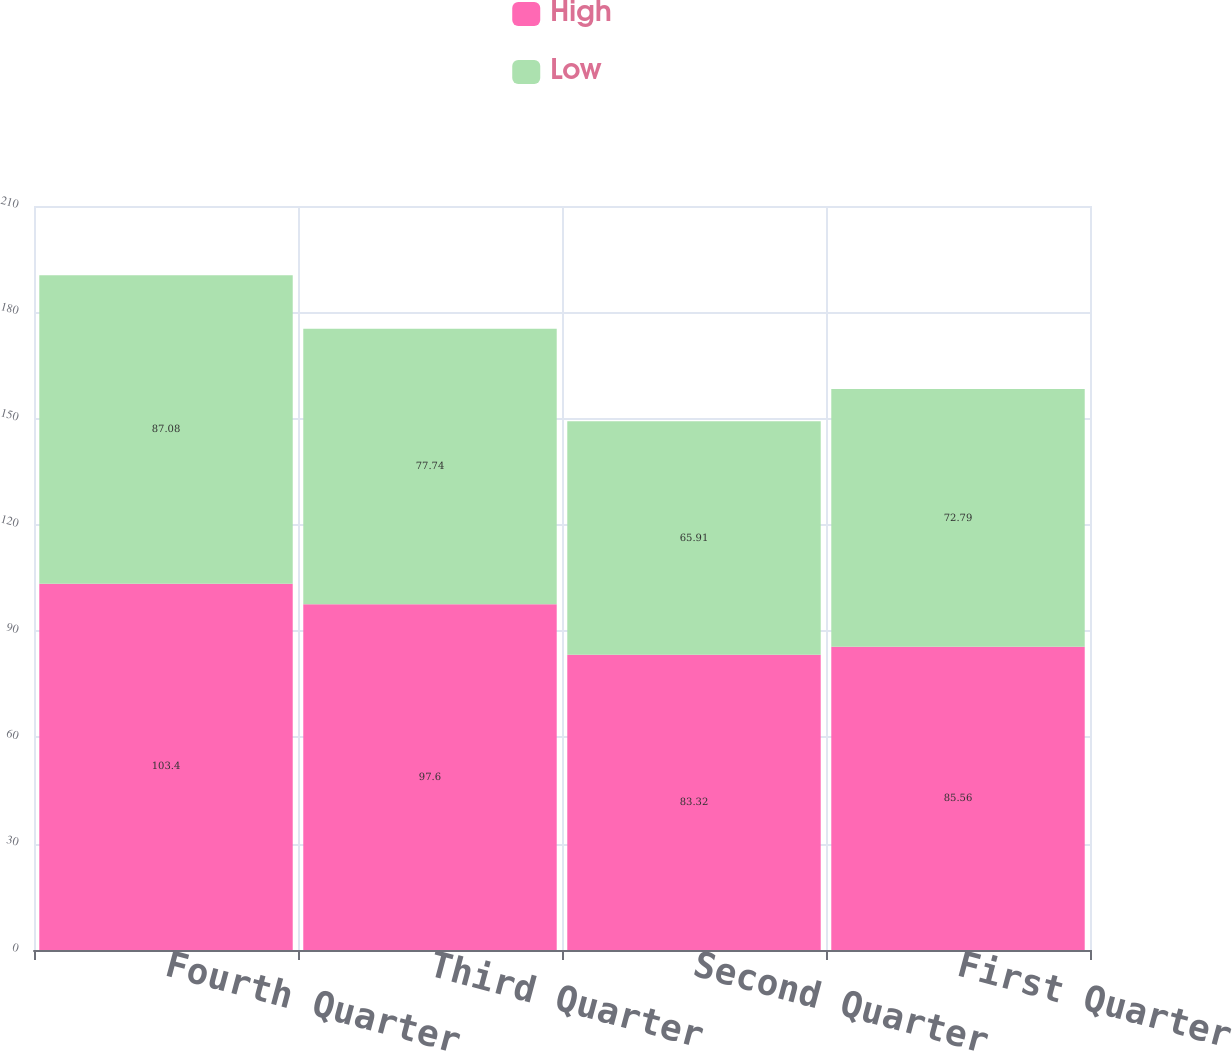<chart> <loc_0><loc_0><loc_500><loc_500><stacked_bar_chart><ecel><fcel>Fourth Quarter<fcel>Third Quarter<fcel>Second Quarter<fcel>First Quarter<nl><fcel>High<fcel>103.4<fcel>97.6<fcel>83.32<fcel>85.56<nl><fcel>Low<fcel>87.08<fcel>77.74<fcel>65.91<fcel>72.79<nl></chart> 